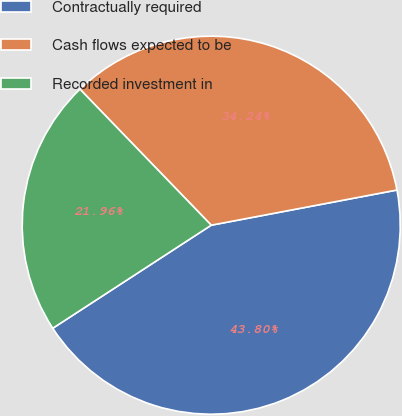<chart> <loc_0><loc_0><loc_500><loc_500><pie_chart><fcel>Contractually required<fcel>Cash flows expected to be<fcel>Recorded investment in<nl><fcel>43.8%<fcel>34.24%<fcel>21.96%<nl></chart> 